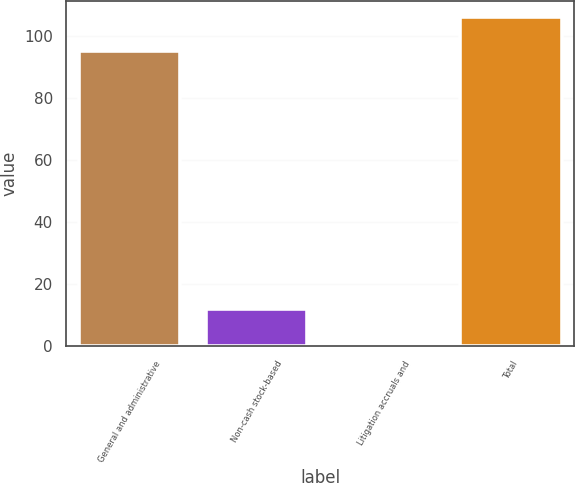<chart> <loc_0><loc_0><loc_500><loc_500><bar_chart><fcel>General and administrative<fcel>Non-cash stock-based<fcel>Litigation accruals and<fcel>Total<nl><fcel>95<fcel>12<fcel>1<fcel>106<nl></chart> 